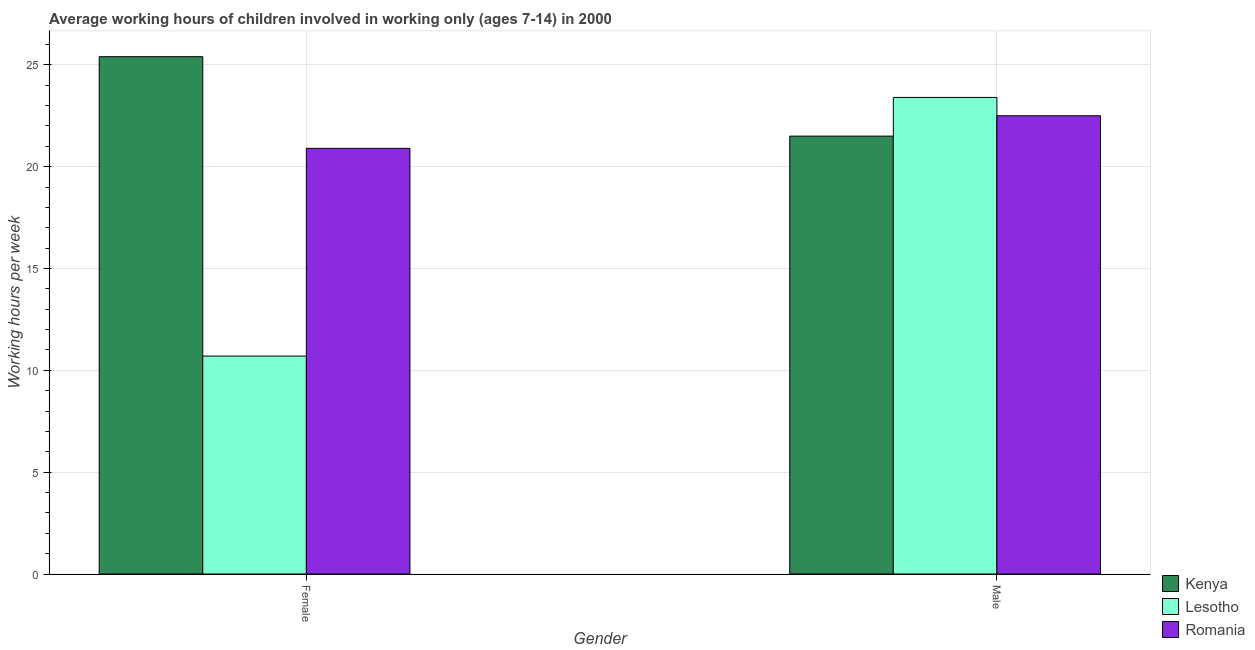How many groups of bars are there?
Provide a succinct answer. 2. Are the number of bars on each tick of the X-axis equal?
Provide a short and direct response. Yes. How many bars are there on the 2nd tick from the right?
Ensure brevity in your answer.  3. What is the label of the 2nd group of bars from the left?
Make the answer very short. Male. Across all countries, what is the maximum average working hour of female children?
Provide a succinct answer. 25.4. In which country was the average working hour of male children maximum?
Offer a terse response. Lesotho. In which country was the average working hour of male children minimum?
Your answer should be very brief. Kenya. What is the total average working hour of female children in the graph?
Offer a very short reply. 57. What is the difference between the average working hour of male children in Romania and that in Lesotho?
Offer a very short reply. -0.9. What is the difference between the average working hour of female children in Romania and the average working hour of male children in Lesotho?
Offer a very short reply. -2.5. What is the average average working hour of male children per country?
Provide a succinct answer. 22.47. What is the difference between the average working hour of male children and average working hour of female children in Kenya?
Your response must be concise. -3.9. In how many countries, is the average working hour of male children greater than 18 hours?
Provide a succinct answer. 3. What is the ratio of the average working hour of female children in Kenya to that in Romania?
Give a very brief answer. 1.22. In how many countries, is the average working hour of female children greater than the average average working hour of female children taken over all countries?
Your answer should be compact. 2. What does the 2nd bar from the left in Male represents?
Provide a succinct answer. Lesotho. What does the 2nd bar from the right in Female represents?
Provide a succinct answer. Lesotho. How many countries are there in the graph?
Ensure brevity in your answer.  3. What is the difference between two consecutive major ticks on the Y-axis?
Keep it short and to the point. 5. Are the values on the major ticks of Y-axis written in scientific E-notation?
Give a very brief answer. No. Where does the legend appear in the graph?
Your answer should be very brief. Bottom right. What is the title of the graph?
Your answer should be compact. Average working hours of children involved in working only (ages 7-14) in 2000. Does "East Asia (developing only)" appear as one of the legend labels in the graph?
Keep it short and to the point. No. What is the label or title of the X-axis?
Your answer should be very brief. Gender. What is the label or title of the Y-axis?
Give a very brief answer. Working hours per week. What is the Working hours per week of Kenya in Female?
Your answer should be very brief. 25.4. What is the Working hours per week of Romania in Female?
Offer a very short reply. 20.9. What is the Working hours per week in Lesotho in Male?
Give a very brief answer. 23.4. Across all Gender, what is the maximum Working hours per week in Kenya?
Provide a succinct answer. 25.4. Across all Gender, what is the maximum Working hours per week of Lesotho?
Your answer should be compact. 23.4. Across all Gender, what is the minimum Working hours per week in Lesotho?
Ensure brevity in your answer.  10.7. Across all Gender, what is the minimum Working hours per week of Romania?
Ensure brevity in your answer.  20.9. What is the total Working hours per week of Kenya in the graph?
Ensure brevity in your answer.  46.9. What is the total Working hours per week of Lesotho in the graph?
Your answer should be compact. 34.1. What is the total Working hours per week in Romania in the graph?
Provide a succinct answer. 43.4. What is the difference between the Working hours per week in Romania in Female and that in Male?
Offer a very short reply. -1.6. What is the difference between the Working hours per week of Kenya in Female and the Working hours per week of Romania in Male?
Make the answer very short. 2.9. What is the difference between the Working hours per week of Lesotho in Female and the Working hours per week of Romania in Male?
Keep it short and to the point. -11.8. What is the average Working hours per week of Kenya per Gender?
Make the answer very short. 23.45. What is the average Working hours per week of Lesotho per Gender?
Offer a very short reply. 17.05. What is the average Working hours per week of Romania per Gender?
Provide a succinct answer. 21.7. What is the difference between the Working hours per week in Kenya and Working hours per week in Lesotho in Female?
Your answer should be very brief. 14.7. What is the difference between the Working hours per week in Kenya and Working hours per week in Lesotho in Male?
Keep it short and to the point. -1.9. What is the difference between the Working hours per week in Kenya and Working hours per week in Romania in Male?
Offer a terse response. -1. What is the difference between the Working hours per week of Lesotho and Working hours per week of Romania in Male?
Ensure brevity in your answer.  0.9. What is the ratio of the Working hours per week of Kenya in Female to that in Male?
Your response must be concise. 1.18. What is the ratio of the Working hours per week of Lesotho in Female to that in Male?
Provide a short and direct response. 0.46. What is the ratio of the Working hours per week in Romania in Female to that in Male?
Your answer should be compact. 0.93. What is the difference between the highest and the second highest Working hours per week in Kenya?
Provide a succinct answer. 3.9. What is the difference between the highest and the lowest Working hours per week in Kenya?
Provide a succinct answer. 3.9. What is the difference between the highest and the lowest Working hours per week in Romania?
Provide a short and direct response. 1.6. 